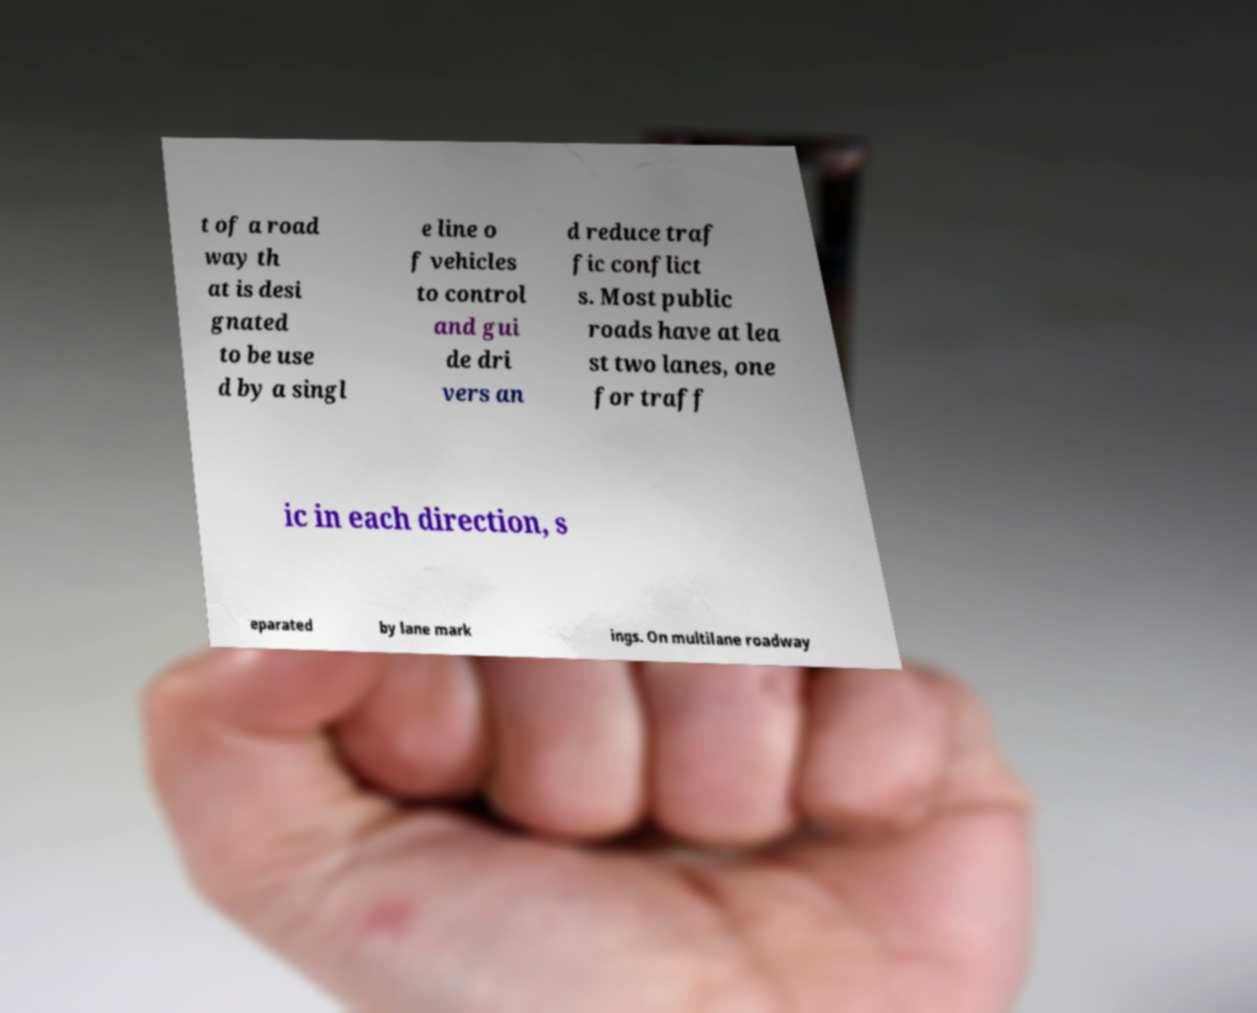Can you accurately transcribe the text from the provided image for me? t of a road way th at is desi gnated to be use d by a singl e line o f vehicles to control and gui de dri vers an d reduce traf fic conflict s. Most public roads have at lea st two lanes, one for traff ic in each direction, s eparated by lane mark ings. On multilane roadway 